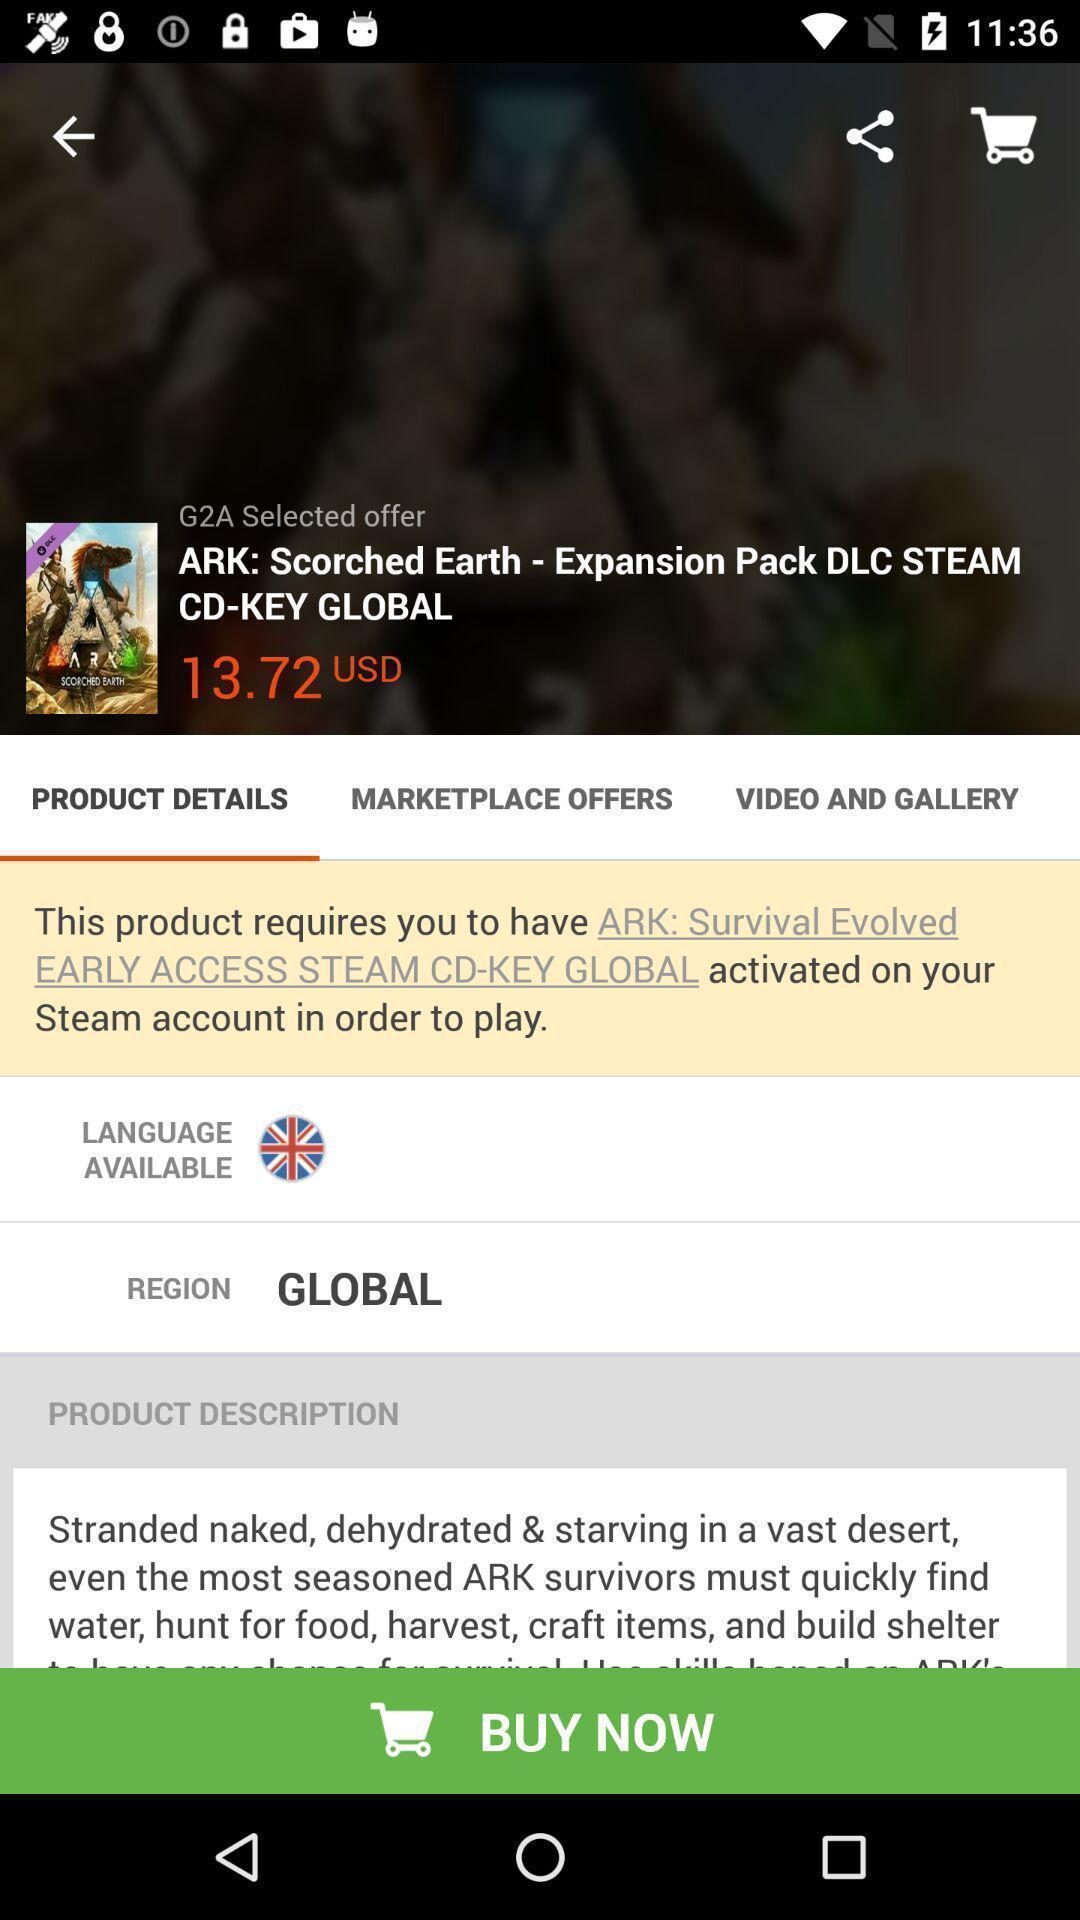Summarize the information in this screenshot. Start page of a game in a gaming application. 